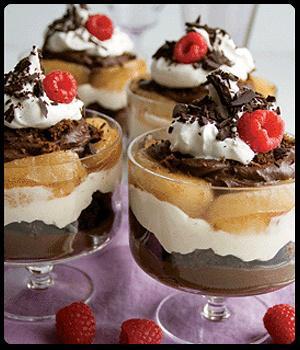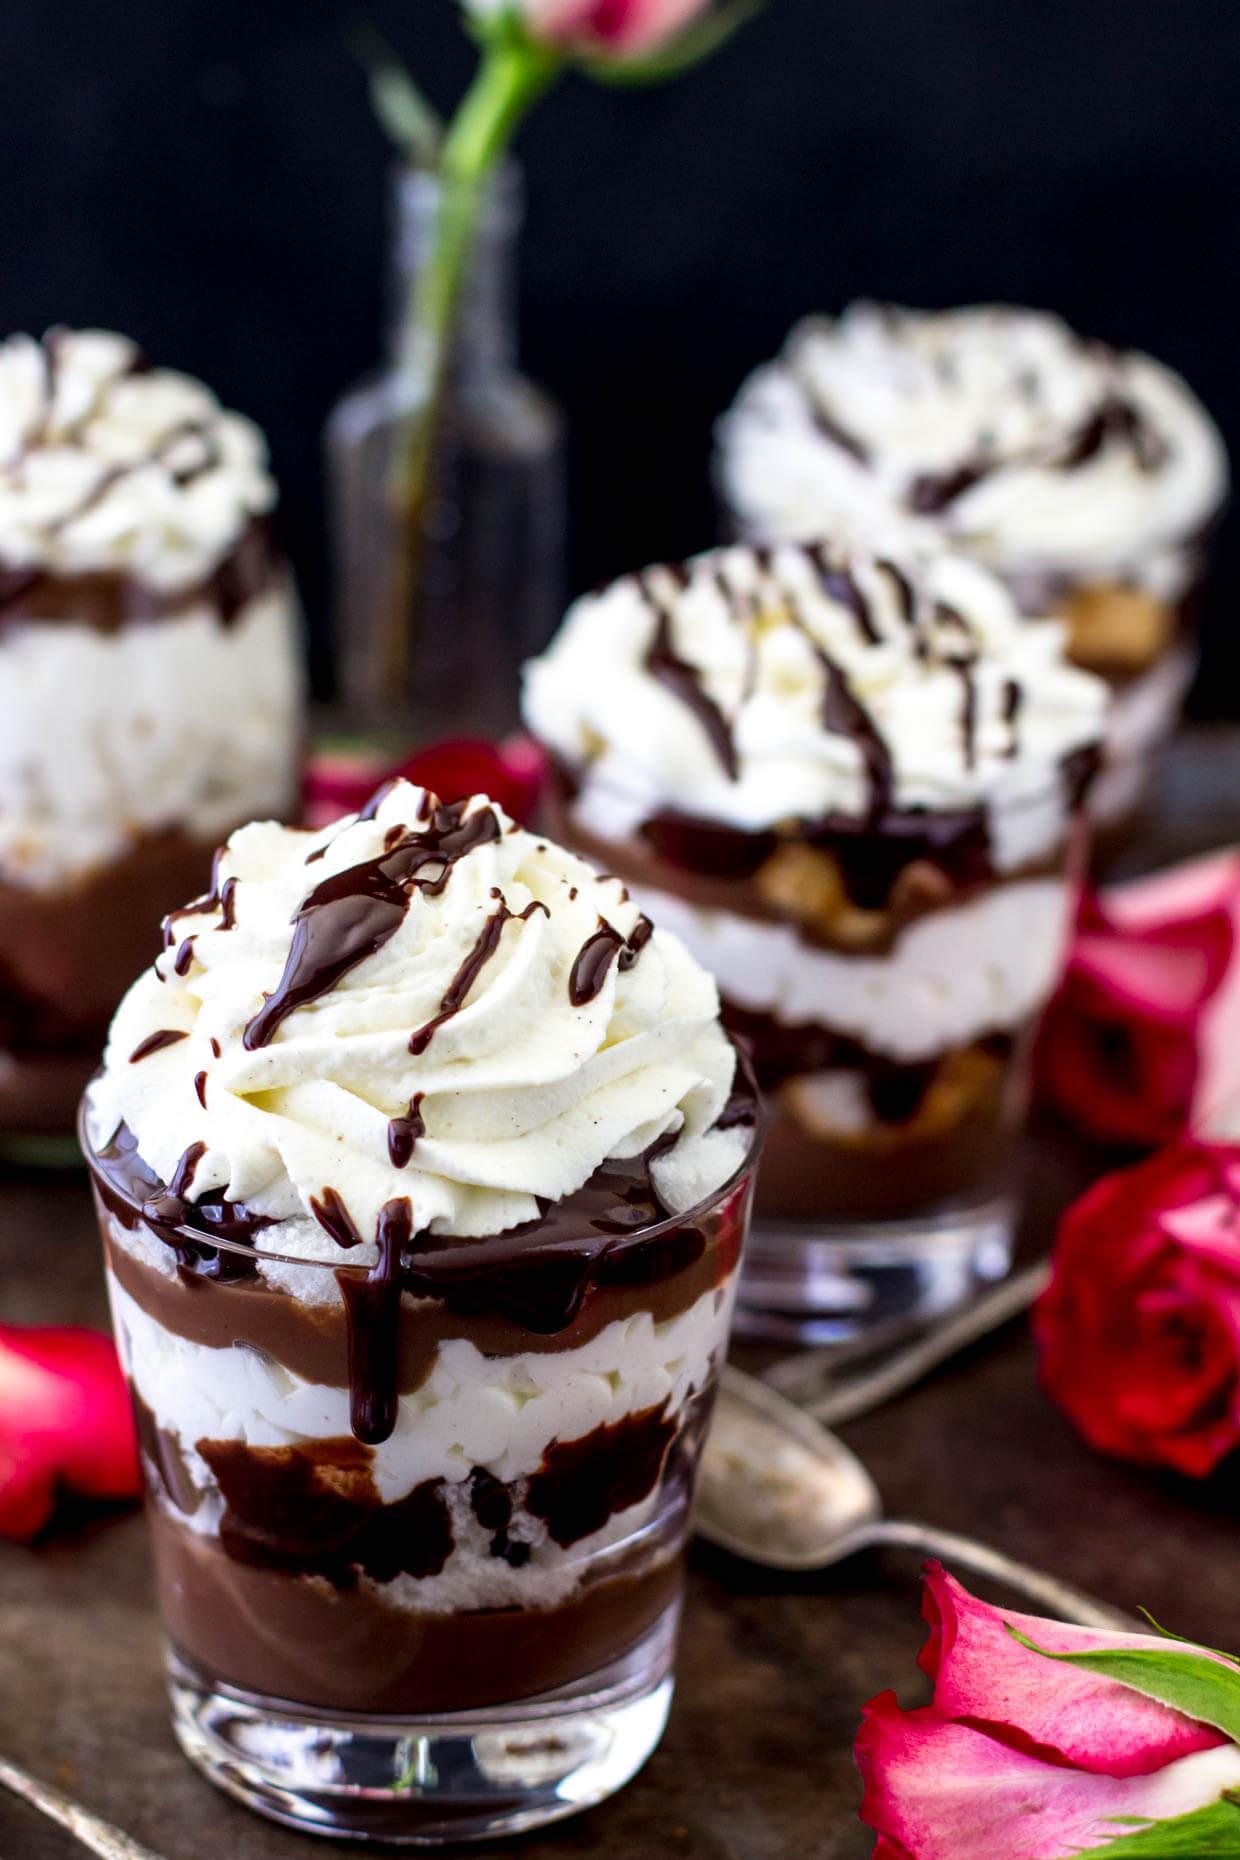The first image is the image on the left, the second image is the image on the right. Given the left and right images, does the statement "there are roses on the table next to desserts with chocolate drizzled on top" hold true? Answer yes or no. Yes. The first image is the image on the left, the second image is the image on the right. For the images shown, is this caption "6 desserts feature a bread/cake like filling." true? Answer yes or no. Yes. 